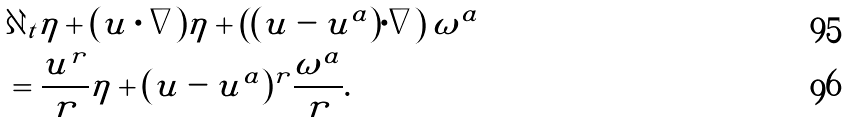Convert formula to latex. <formula><loc_0><loc_0><loc_500><loc_500>& \partial _ { t } \eta + ( u \cdot \nabla ) \eta + \left ( ( u - u ^ { a } ) \cdot \nabla \right ) \omega ^ { a } \\ & = \frac { u ^ { r } } r \eta + ( u - u ^ { a } ) ^ { r } \frac { \omega ^ { a } } r .</formula> 